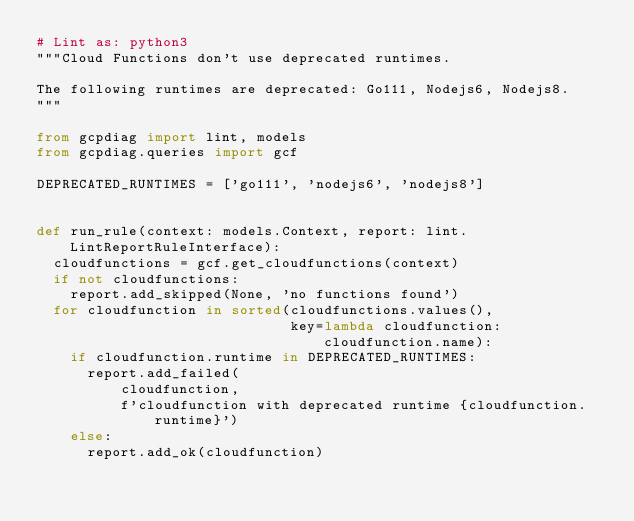Convert code to text. <code><loc_0><loc_0><loc_500><loc_500><_Python_># Lint as: python3
"""Cloud Functions don't use deprecated runtimes.

The following runtimes are deprecated: Go111, Nodejs6, Nodejs8.
"""

from gcpdiag import lint, models
from gcpdiag.queries import gcf

DEPRECATED_RUNTIMES = ['go111', 'nodejs6', 'nodejs8']


def run_rule(context: models.Context, report: lint.LintReportRuleInterface):
  cloudfunctions = gcf.get_cloudfunctions(context)
  if not cloudfunctions:
    report.add_skipped(None, 'no functions found')
  for cloudfunction in sorted(cloudfunctions.values(),
                              key=lambda cloudfunction: cloudfunction.name):
    if cloudfunction.runtime in DEPRECATED_RUNTIMES:
      report.add_failed(
          cloudfunction,
          f'cloudfunction with deprecated runtime {cloudfunction.runtime}')
    else:
      report.add_ok(cloudfunction)
</code> 